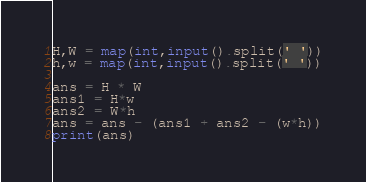Convert code to text. <code><loc_0><loc_0><loc_500><loc_500><_Python_>H,W = map(int,input().split(' '))
h,w = map(int,input().split(' '))

ans = H * W
ans1 = H*w
ans2 = W*h
ans = ans - (ans1 + ans2 - (w*h))
print(ans)</code> 